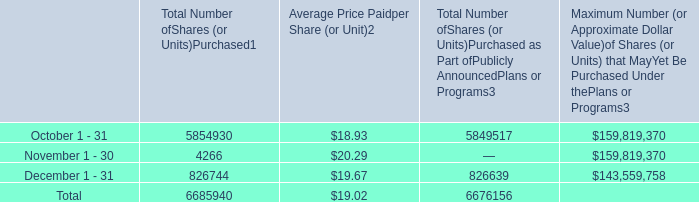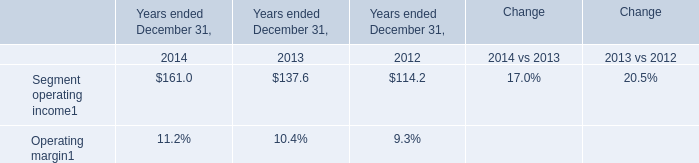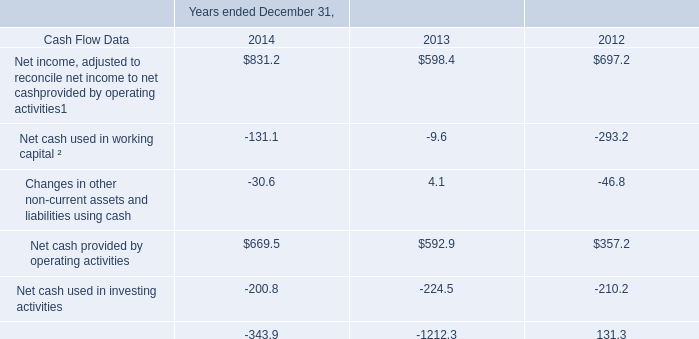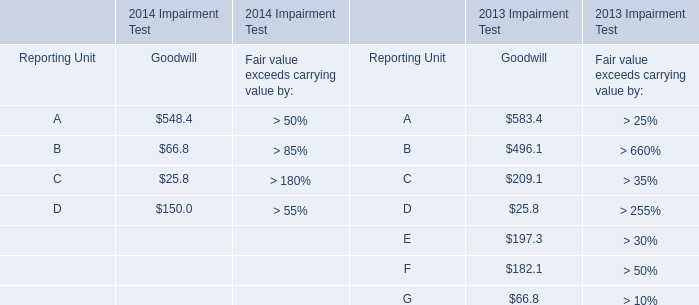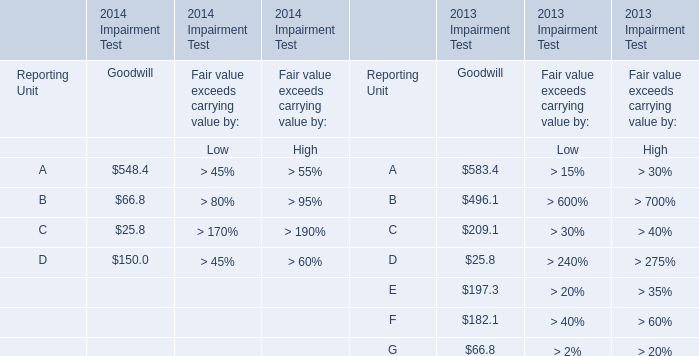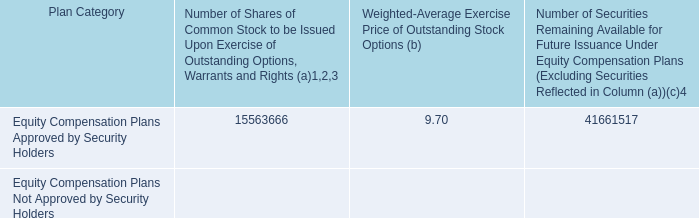For 2013 Impairment Test,what is the total value of the Goodwill of A, the Goodwill of B, the Goodwill of C and the Goodwill of D? 
Computations: (((583.4 + 496.1) + 209.1) + 25.8)
Answer: 1314.4. 